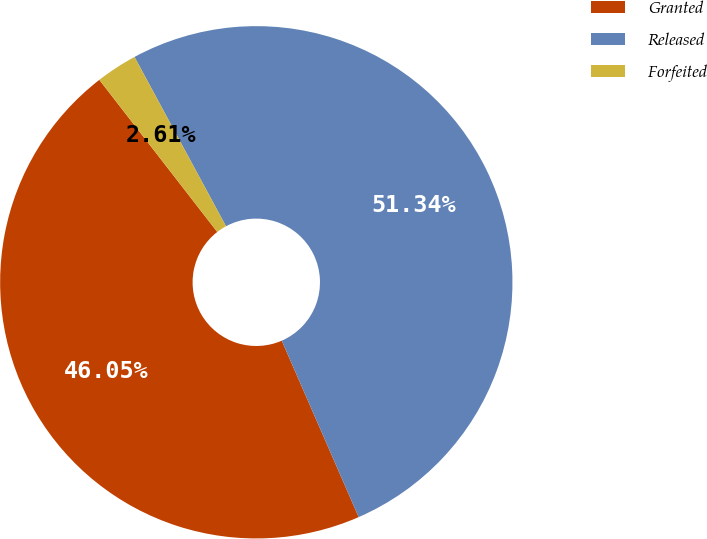Convert chart. <chart><loc_0><loc_0><loc_500><loc_500><pie_chart><fcel>Granted<fcel>Released<fcel>Forfeited<nl><fcel>46.05%<fcel>51.34%<fcel>2.61%<nl></chart> 